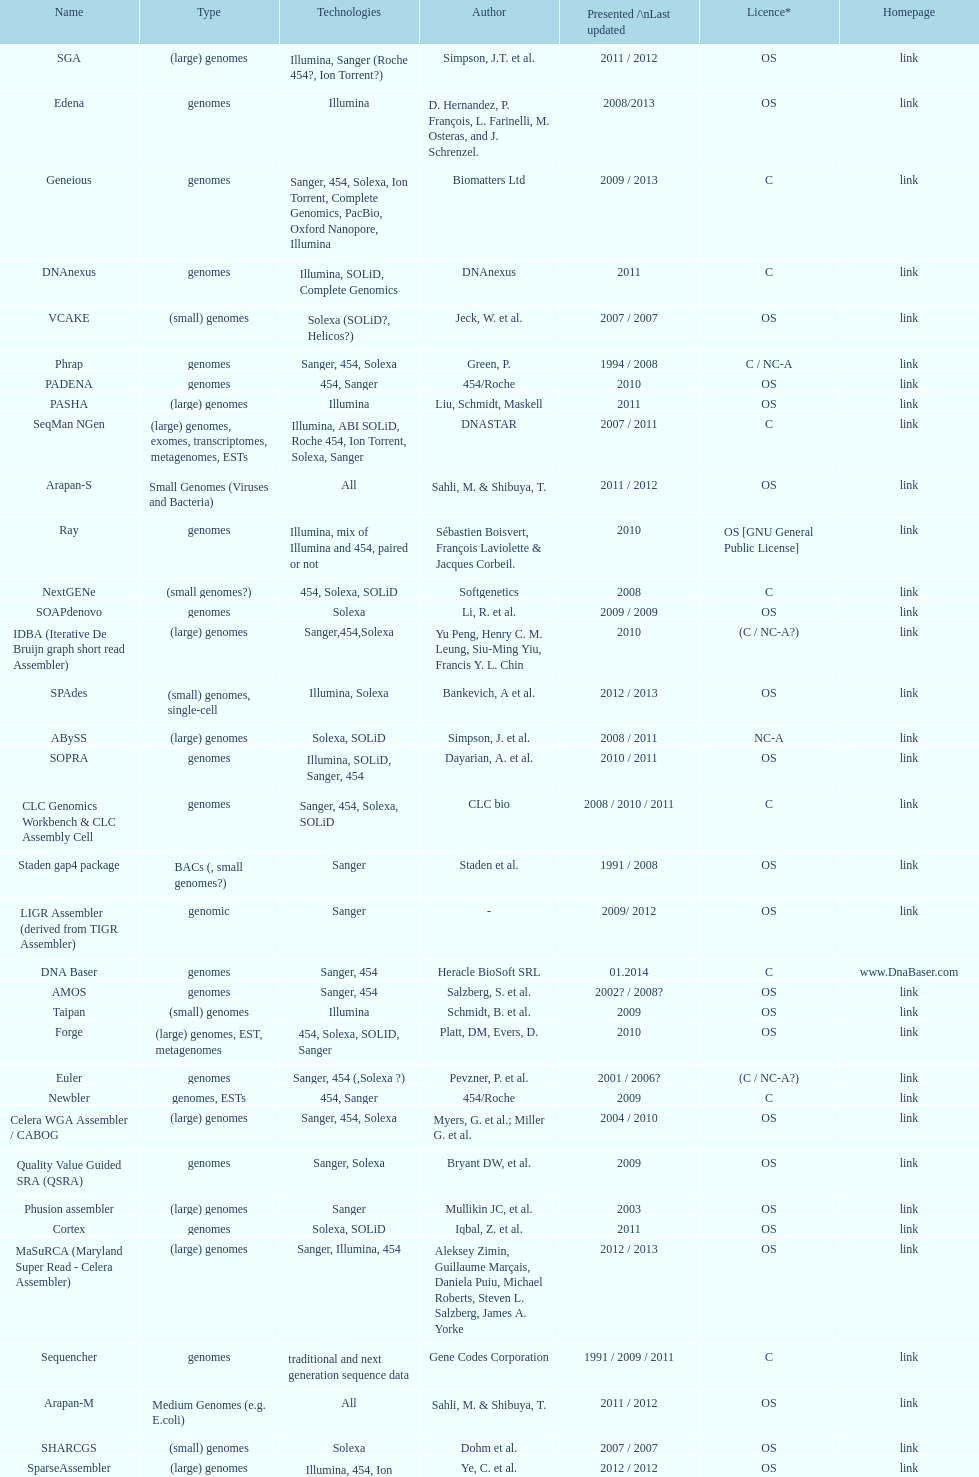What was the total number of times sahi, m. & shilbuya, t. listed as co-authors? 2. 